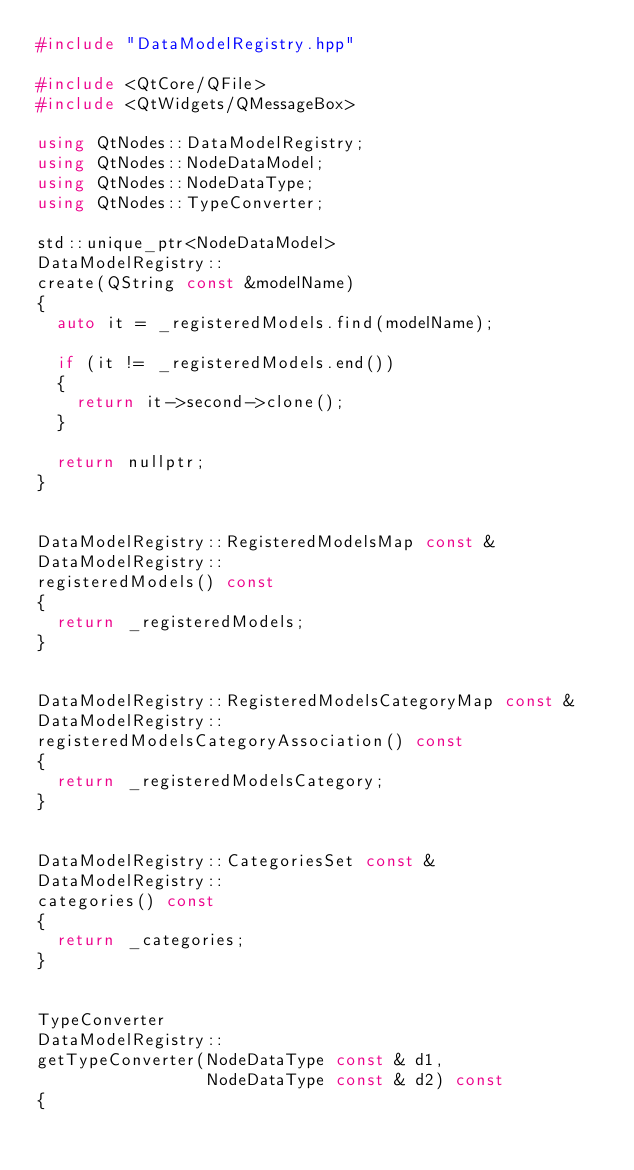<code> <loc_0><loc_0><loc_500><loc_500><_C++_>#include "DataModelRegistry.hpp"

#include <QtCore/QFile>
#include <QtWidgets/QMessageBox>

using QtNodes::DataModelRegistry;
using QtNodes::NodeDataModel;
using QtNodes::NodeDataType;
using QtNodes::TypeConverter;

std::unique_ptr<NodeDataModel>
DataModelRegistry::
create(QString const &modelName)
{
  auto it = _registeredModels.find(modelName);

  if (it != _registeredModels.end())
  {
    return it->second->clone();
  }

  return nullptr;
}


DataModelRegistry::RegisteredModelsMap const &
DataModelRegistry::
registeredModels() const
{
  return _registeredModels;
}


DataModelRegistry::RegisteredModelsCategoryMap const &
DataModelRegistry::
registeredModelsCategoryAssociation() const
{
  return _registeredModelsCategory;
}


DataModelRegistry::CategoriesSet const &
DataModelRegistry::
categories() const
{
  return _categories;
}


TypeConverter
DataModelRegistry::
getTypeConverter(NodeDataType const & d1,
                 NodeDataType const & d2) const
{</code> 